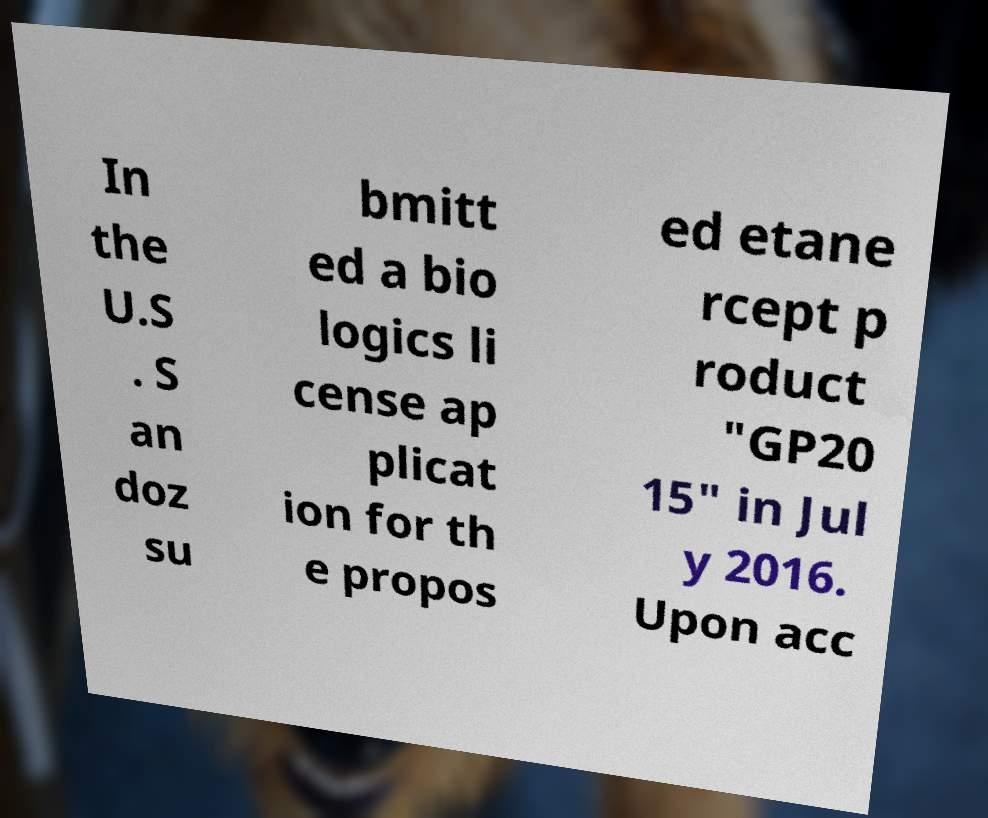Could you assist in decoding the text presented in this image and type it out clearly? In the U.S . S an doz su bmitt ed a bio logics li cense ap plicat ion for th e propos ed etane rcept p roduct "GP20 15" in Jul y 2016. Upon acc 